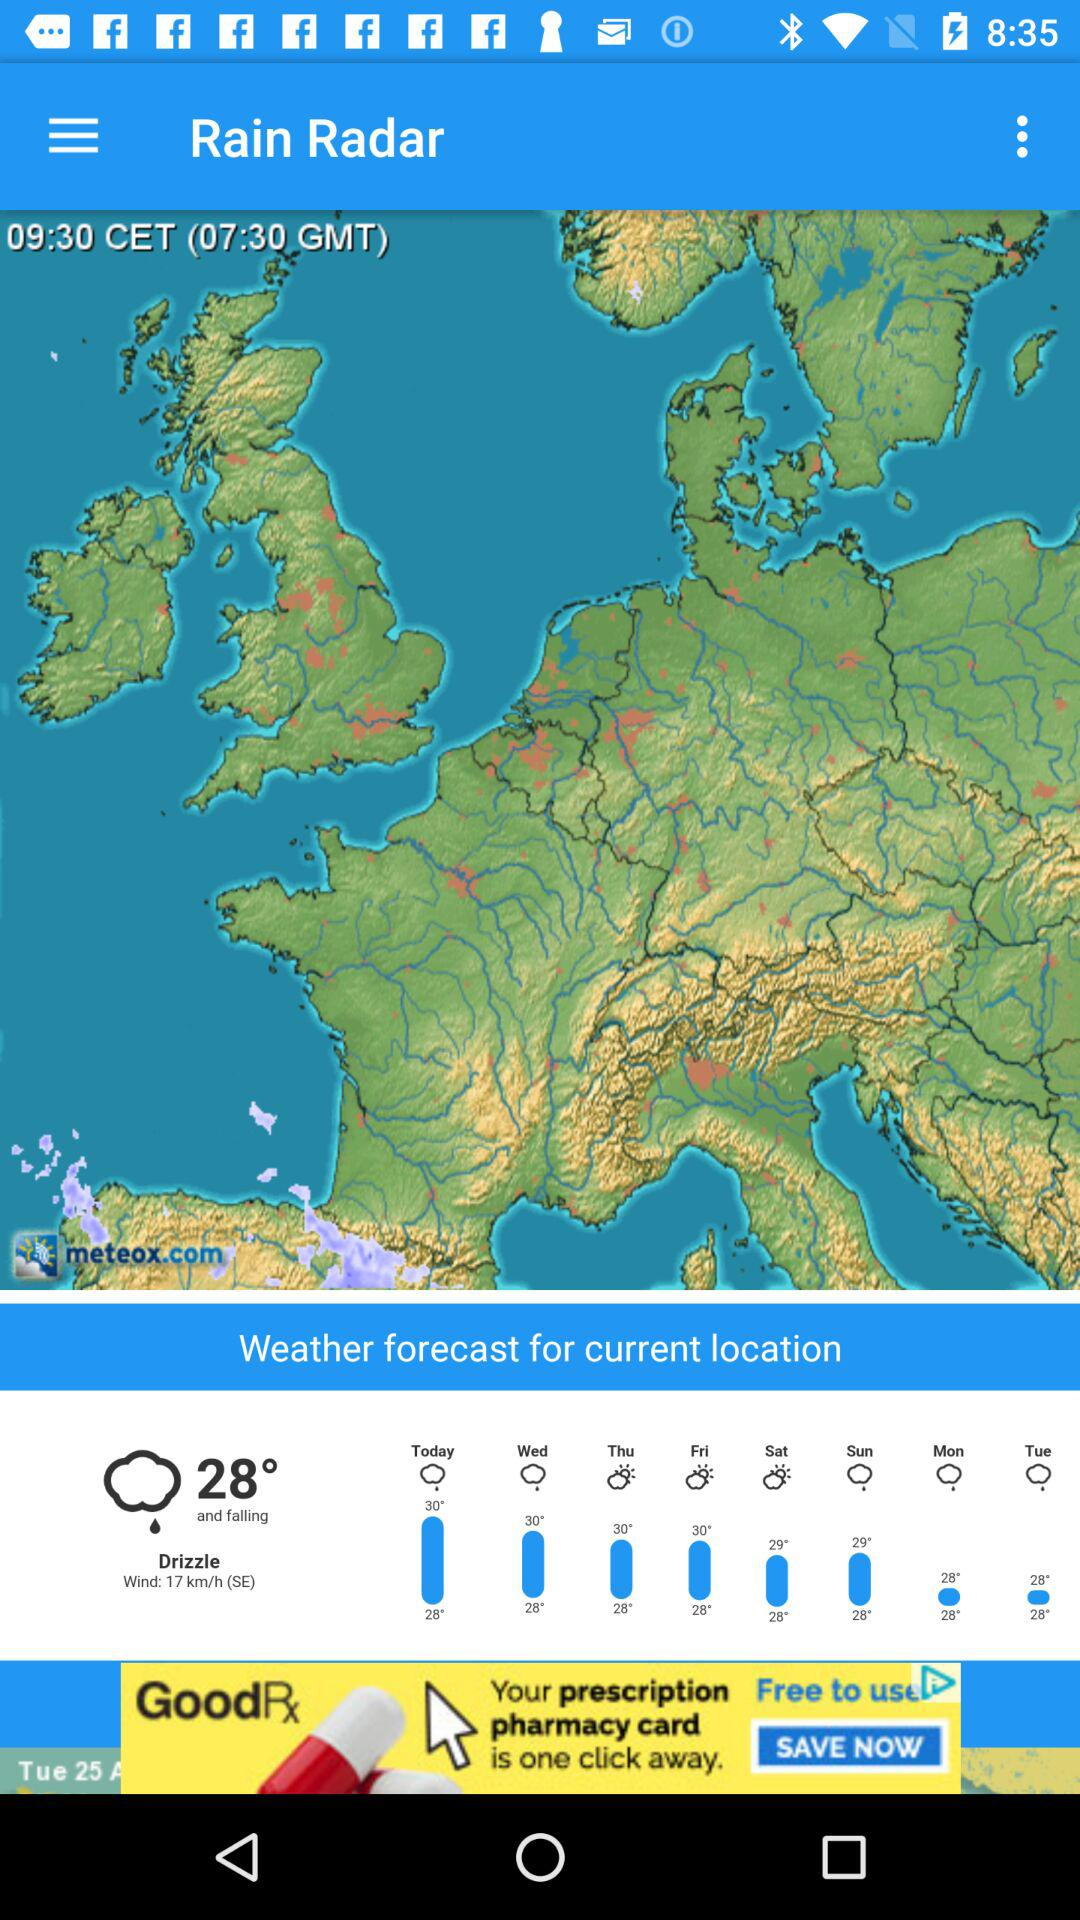What's the weather and temperature? The weather is drizzly and the temperature is 28°. 